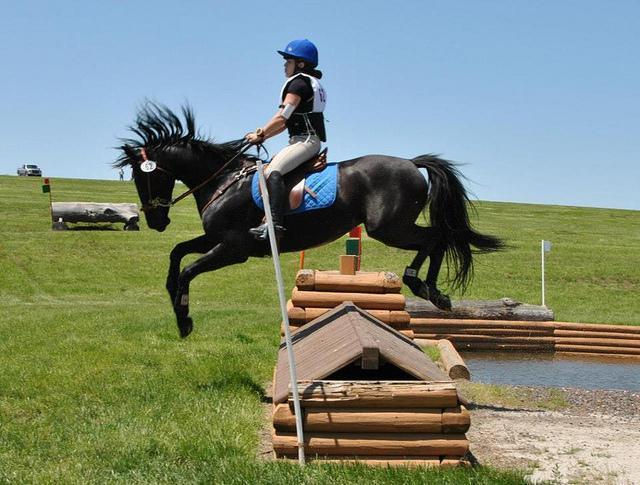How many horses are there?
Give a very brief answer. 2. 